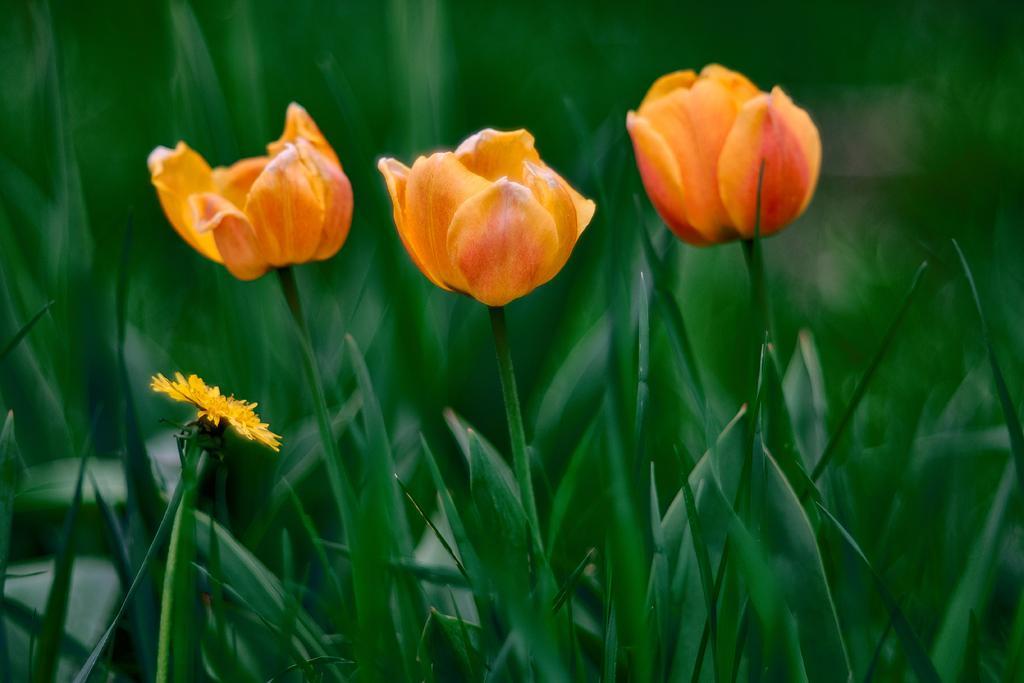Can you describe this image briefly? In this picture there are few flowers which are in yellow and orange in color and the background is greenery. 